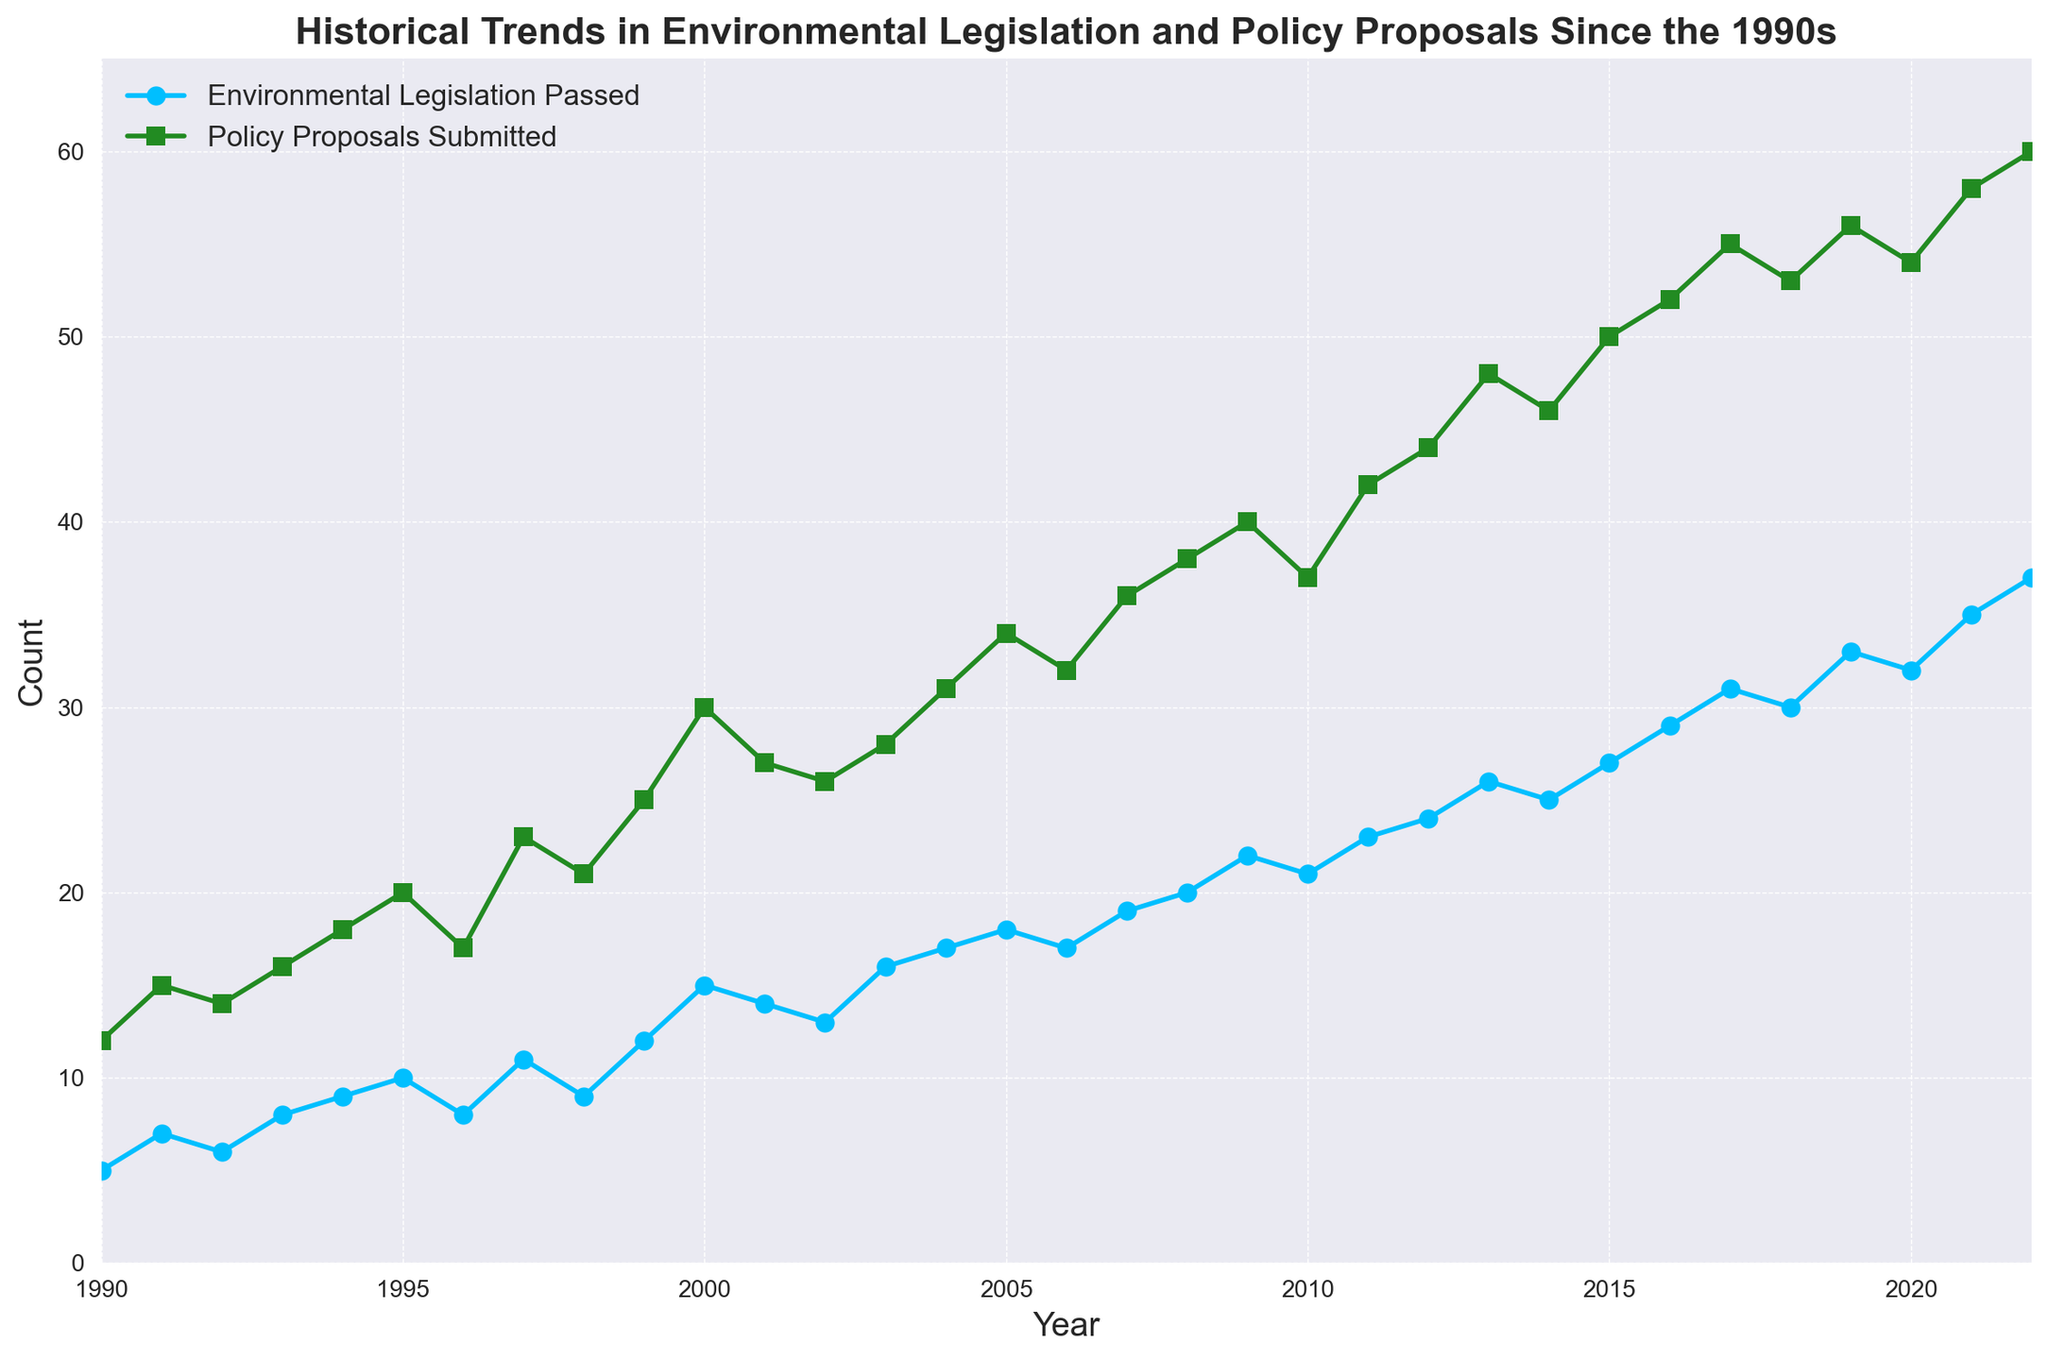Which year had the highest number of environmental legislation passed? Look for the year where the 'Environmental Legislation Passed' line reaches its peak point. It reaches 37 in the year 2022.
Answer: 2022 Are there any years where the number of policy proposals submitted equals the number of environmental legislation passed? Compare the values of both lines across all years. There are no years where the counts match exactly.
Answer: No What is the average number of environmental legislation passed between 1990 and 2000? To find the average, add the counts from 1990 to 2000 (5+7+6+8+9+10+8+11+9+12+15 = 100), then divide by the number of years (11).
Answer: 9.09 By how much did the number of policy proposals submitted increase from 1990 to 2022? Subtract the number of policy proposals submitted in 1990 (12) from the number submitted in 2022 (60).
Answer: 48 What was the difference between the number of policy proposals submitted and environmental legislation passed in 2010? Find the values for 2010 (Policy Proposals Submitted: 37, Environmental Legislation Passed: 21) and calculate the difference 37 - 21.
Answer: 16 In which year did the number of policy proposals submitted first exceed 50? Search for the year where the 'Policy Proposals Submitted' line first crosses the 50 mark. This occurs in 2015.
Answer: 2015 Is there a noticeable trend in the number of environmental legislation passed since the 1990s? Observe the overall direction of the 'Environmental Legislation Passed' line from 1990 onward. It's generally increasing.
Answer: Yes How many more environmental legislations were passed in 2020 compared to 1990? Subtract the number for 1990 (5) from the number for 2020 (32).
Answer: 27 In 2005, how many more policy proposals were submitted compared to environmental legislation passed? Compare the counts for 2005 (Policy Proposals Submitted: 34, Environmental Legislation Passed: 18) and calculate 34 - 18.
Answer: 16 During which period did both the number of policy proposals submitted and environmental legislation passed show the most significant increase? Compare the slopes of the lines for different periods. Both lines have steeper slopes between 2010 and 2022.
Answer: 2010-2022 